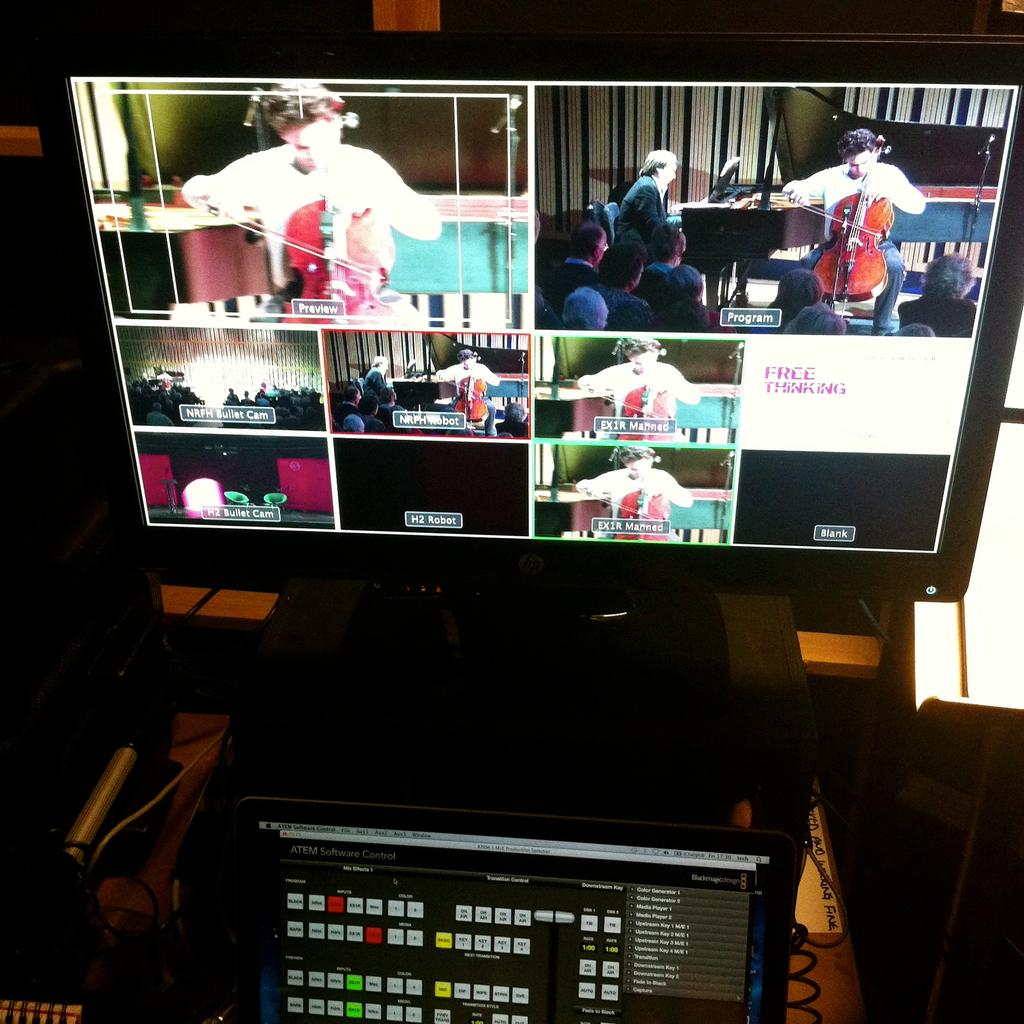<image>
Render a clear and concise summary of the photo. A monitor displays a number of boxes, one box reads "free thinking." 